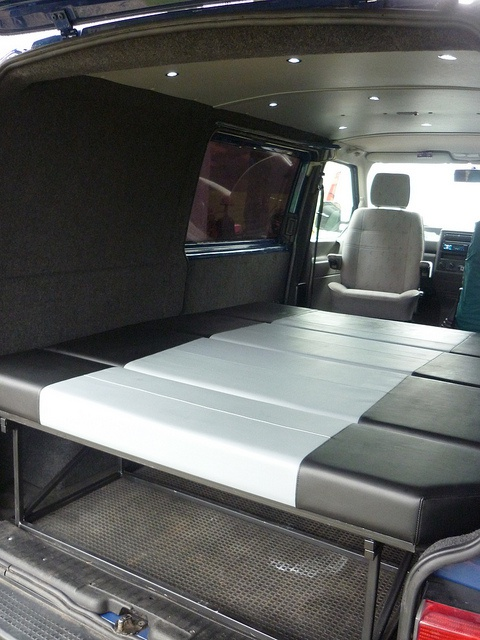Describe the objects in this image and their specific colors. I can see car in black, gray, white, darkgray, and lightgray tones, bed in gray, lightgray, darkgray, and black tones, and chair in gray, lightgray, darkgray, and black tones in this image. 